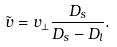<formula> <loc_0><loc_0><loc_500><loc_500>\tilde { v } = v _ { \perp } \frac { D _ { s } } { D _ { s } - D _ { l } } .</formula> 